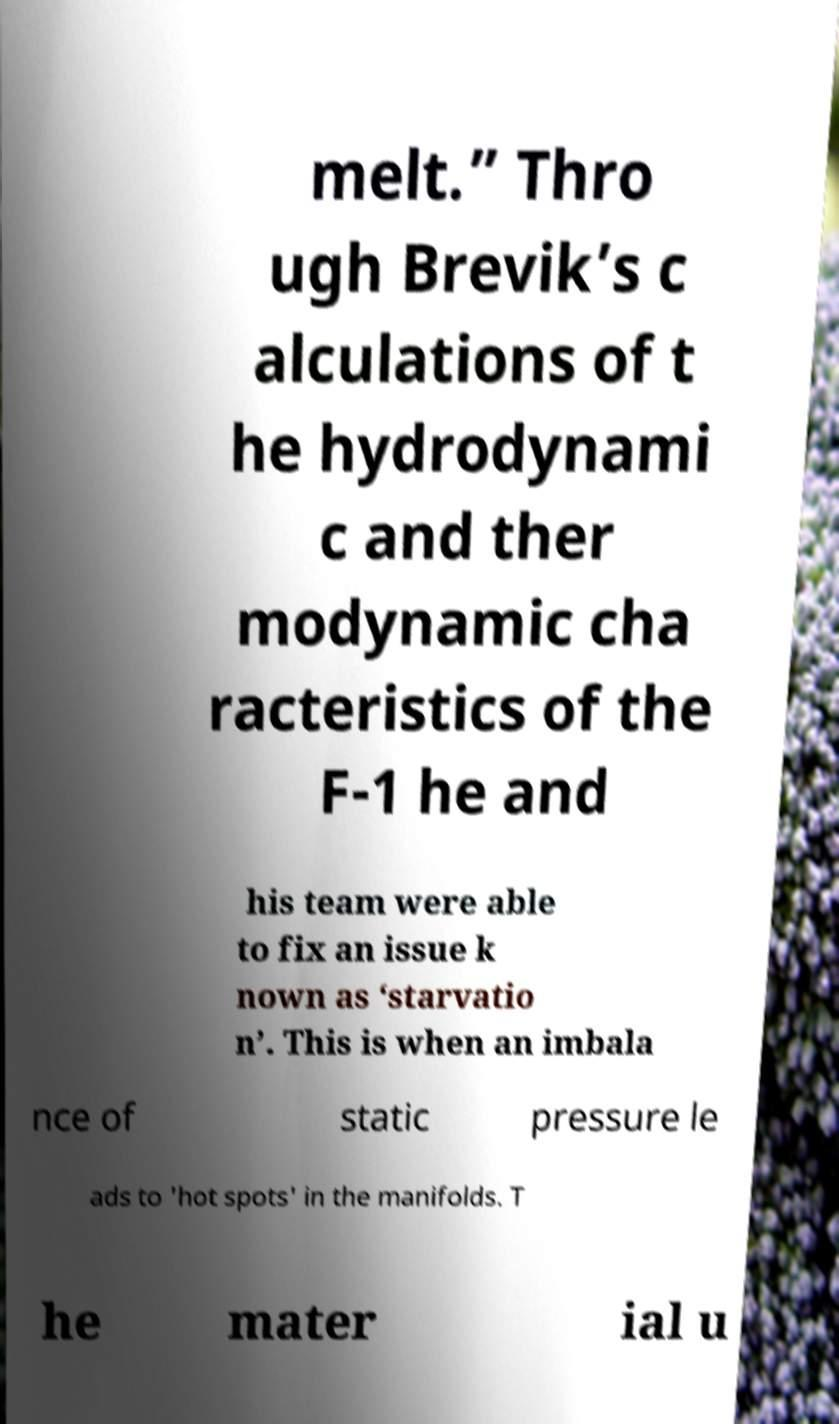I need the written content from this picture converted into text. Can you do that? melt.” Thro ugh Brevik’s c alculations of t he hydrodynami c and ther modynamic cha racteristics of the F-1 he and his team were able to fix an issue k nown as ‘starvatio n’. This is when an imbala nce of static pressure le ads to 'hot spots' in the manifolds. T he mater ial u 